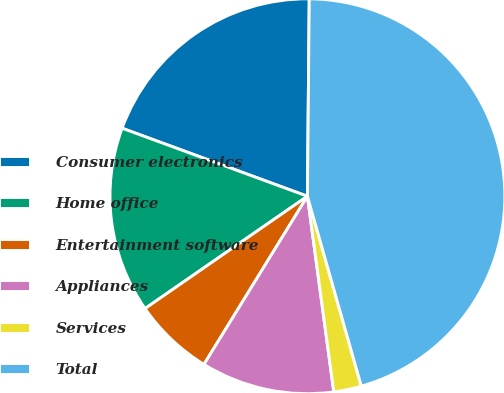<chart> <loc_0><loc_0><loc_500><loc_500><pie_chart><fcel>Consumer electronics<fcel>Home office<fcel>Entertainment software<fcel>Appliances<fcel>Services<fcel>Total<nl><fcel>19.55%<fcel>15.23%<fcel>6.59%<fcel>10.91%<fcel>2.27%<fcel>45.45%<nl></chart> 